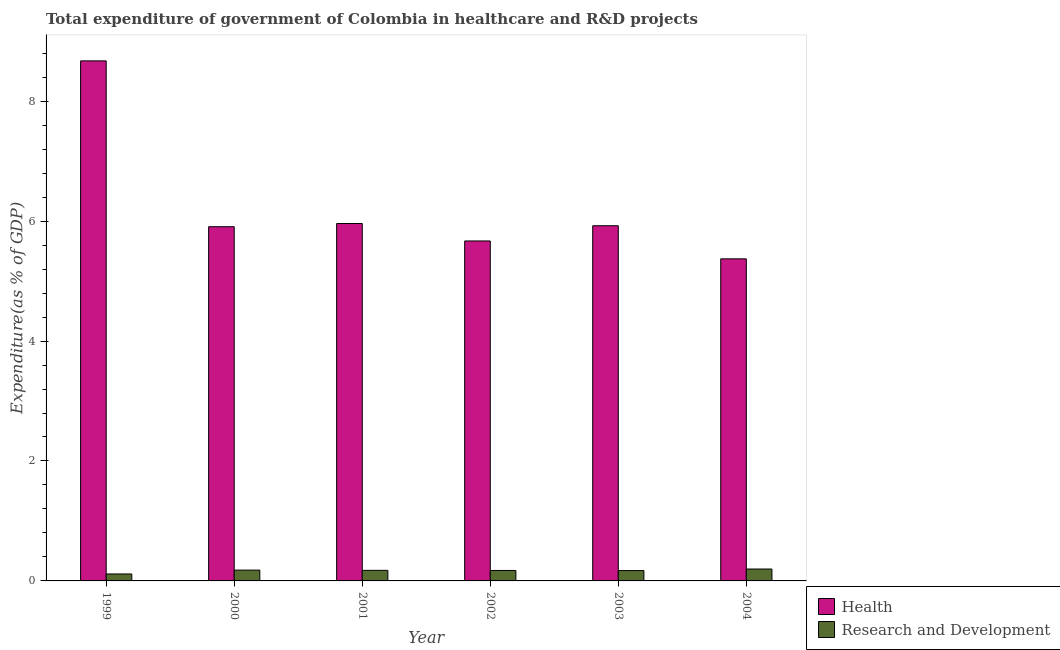How many groups of bars are there?
Provide a short and direct response. 6. How many bars are there on the 4th tick from the left?
Keep it short and to the point. 2. What is the expenditure in healthcare in 2003?
Your response must be concise. 5.92. Across all years, what is the maximum expenditure in healthcare?
Your response must be concise. 8.67. Across all years, what is the minimum expenditure in r&d?
Your answer should be very brief. 0.12. In which year was the expenditure in r&d maximum?
Your answer should be very brief. 2004. In which year was the expenditure in r&d minimum?
Your answer should be very brief. 1999. What is the total expenditure in r&d in the graph?
Provide a succinct answer. 1.02. What is the difference between the expenditure in r&d in 2000 and that in 2001?
Offer a very short reply. 0. What is the difference between the expenditure in r&d in 1999 and the expenditure in healthcare in 2000?
Give a very brief answer. -0.06. What is the average expenditure in r&d per year?
Ensure brevity in your answer.  0.17. In how many years, is the expenditure in healthcare greater than 8.4 %?
Keep it short and to the point. 1. What is the ratio of the expenditure in healthcare in 2001 to that in 2004?
Your answer should be compact. 1.11. Is the expenditure in healthcare in 2000 less than that in 2001?
Your response must be concise. Yes. What is the difference between the highest and the second highest expenditure in healthcare?
Offer a terse response. 2.71. What is the difference between the highest and the lowest expenditure in healthcare?
Your answer should be very brief. 3.3. What does the 2nd bar from the left in 2003 represents?
Ensure brevity in your answer.  Research and Development. What does the 2nd bar from the right in 2003 represents?
Provide a short and direct response. Health. Are all the bars in the graph horizontal?
Give a very brief answer. No. What is the difference between two consecutive major ticks on the Y-axis?
Keep it short and to the point. 2. What is the title of the graph?
Your answer should be compact. Total expenditure of government of Colombia in healthcare and R&D projects. Does "Commercial bank branches" appear as one of the legend labels in the graph?
Your answer should be very brief. No. What is the label or title of the Y-axis?
Offer a terse response. Expenditure(as % of GDP). What is the Expenditure(as % of GDP) in Health in 1999?
Offer a very short reply. 8.67. What is the Expenditure(as % of GDP) of Research and Development in 1999?
Keep it short and to the point. 0.12. What is the Expenditure(as % of GDP) of Health in 2000?
Offer a terse response. 5.91. What is the Expenditure(as % of GDP) in Research and Development in 2000?
Your answer should be very brief. 0.18. What is the Expenditure(as % of GDP) in Health in 2001?
Provide a short and direct response. 5.96. What is the Expenditure(as % of GDP) in Research and Development in 2001?
Ensure brevity in your answer.  0.18. What is the Expenditure(as % of GDP) in Health in 2002?
Give a very brief answer. 5.67. What is the Expenditure(as % of GDP) in Research and Development in 2002?
Your response must be concise. 0.17. What is the Expenditure(as % of GDP) of Health in 2003?
Offer a very short reply. 5.92. What is the Expenditure(as % of GDP) of Research and Development in 2003?
Your answer should be compact. 0.17. What is the Expenditure(as % of GDP) in Health in 2004?
Offer a terse response. 5.37. What is the Expenditure(as % of GDP) of Research and Development in 2004?
Your response must be concise. 0.2. Across all years, what is the maximum Expenditure(as % of GDP) of Health?
Ensure brevity in your answer.  8.67. Across all years, what is the maximum Expenditure(as % of GDP) of Research and Development?
Ensure brevity in your answer.  0.2. Across all years, what is the minimum Expenditure(as % of GDP) of Health?
Your answer should be very brief. 5.37. Across all years, what is the minimum Expenditure(as % of GDP) of Research and Development?
Make the answer very short. 0.12. What is the total Expenditure(as % of GDP) of Health in the graph?
Give a very brief answer. 37.5. What is the total Expenditure(as % of GDP) of Research and Development in the graph?
Keep it short and to the point. 1.02. What is the difference between the Expenditure(as % of GDP) in Health in 1999 and that in 2000?
Your response must be concise. 2.77. What is the difference between the Expenditure(as % of GDP) of Research and Development in 1999 and that in 2000?
Offer a very short reply. -0.06. What is the difference between the Expenditure(as % of GDP) of Health in 1999 and that in 2001?
Your response must be concise. 2.71. What is the difference between the Expenditure(as % of GDP) of Research and Development in 1999 and that in 2001?
Offer a terse response. -0.06. What is the difference between the Expenditure(as % of GDP) of Health in 1999 and that in 2002?
Your answer should be very brief. 3. What is the difference between the Expenditure(as % of GDP) of Research and Development in 1999 and that in 2002?
Your answer should be compact. -0.06. What is the difference between the Expenditure(as % of GDP) of Health in 1999 and that in 2003?
Ensure brevity in your answer.  2.75. What is the difference between the Expenditure(as % of GDP) in Research and Development in 1999 and that in 2003?
Ensure brevity in your answer.  -0.06. What is the difference between the Expenditure(as % of GDP) of Health in 1999 and that in 2004?
Ensure brevity in your answer.  3.3. What is the difference between the Expenditure(as % of GDP) in Research and Development in 1999 and that in 2004?
Ensure brevity in your answer.  -0.08. What is the difference between the Expenditure(as % of GDP) of Health in 2000 and that in 2001?
Your answer should be very brief. -0.05. What is the difference between the Expenditure(as % of GDP) of Research and Development in 2000 and that in 2001?
Make the answer very short. 0. What is the difference between the Expenditure(as % of GDP) of Health in 2000 and that in 2002?
Your response must be concise. 0.24. What is the difference between the Expenditure(as % of GDP) in Research and Development in 2000 and that in 2002?
Your response must be concise. 0.01. What is the difference between the Expenditure(as % of GDP) in Health in 2000 and that in 2003?
Your response must be concise. -0.02. What is the difference between the Expenditure(as % of GDP) in Research and Development in 2000 and that in 2003?
Offer a terse response. 0.01. What is the difference between the Expenditure(as % of GDP) of Health in 2000 and that in 2004?
Give a very brief answer. 0.54. What is the difference between the Expenditure(as % of GDP) of Research and Development in 2000 and that in 2004?
Ensure brevity in your answer.  -0.02. What is the difference between the Expenditure(as % of GDP) of Health in 2001 and that in 2002?
Provide a succinct answer. 0.29. What is the difference between the Expenditure(as % of GDP) of Research and Development in 2001 and that in 2002?
Offer a very short reply. 0. What is the difference between the Expenditure(as % of GDP) in Health in 2001 and that in 2003?
Provide a succinct answer. 0.04. What is the difference between the Expenditure(as % of GDP) in Research and Development in 2001 and that in 2003?
Your answer should be compact. 0. What is the difference between the Expenditure(as % of GDP) in Health in 2001 and that in 2004?
Keep it short and to the point. 0.59. What is the difference between the Expenditure(as % of GDP) of Research and Development in 2001 and that in 2004?
Your answer should be compact. -0.02. What is the difference between the Expenditure(as % of GDP) of Health in 2002 and that in 2003?
Make the answer very short. -0.25. What is the difference between the Expenditure(as % of GDP) in Research and Development in 2002 and that in 2003?
Provide a succinct answer. 0. What is the difference between the Expenditure(as % of GDP) in Health in 2002 and that in 2004?
Ensure brevity in your answer.  0.3. What is the difference between the Expenditure(as % of GDP) of Research and Development in 2002 and that in 2004?
Provide a succinct answer. -0.02. What is the difference between the Expenditure(as % of GDP) in Health in 2003 and that in 2004?
Your response must be concise. 0.55. What is the difference between the Expenditure(as % of GDP) in Research and Development in 2003 and that in 2004?
Offer a terse response. -0.03. What is the difference between the Expenditure(as % of GDP) in Health in 1999 and the Expenditure(as % of GDP) in Research and Development in 2000?
Provide a short and direct response. 8.49. What is the difference between the Expenditure(as % of GDP) in Health in 1999 and the Expenditure(as % of GDP) in Research and Development in 2001?
Provide a succinct answer. 8.5. What is the difference between the Expenditure(as % of GDP) of Health in 1999 and the Expenditure(as % of GDP) of Research and Development in 2002?
Ensure brevity in your answer.  8.5. What is the difference between the Expenditure(as % of GDP) in Health in 1999 and the Expenditure(as % of GDP) in Research and Development in 2003?
Your response must be concise. 8.5. What is the difference between the Expenditure(as % of GDP) in Health in 1999 and the Expenditure(as % of GDP) in Research and Development in 2004?
Give a very brief answer. 8.47. What is the difference between the Expenditure(as % of GDP) of Health in 2000 and the Expenditure(as % of GDP) of Research and Development in 2001?
Ensure brevity in your answer.  5.73. What is the difference between the Expenditure(as % of GDP) of Health in 2000 and the Expenditure(as % of GDP) of Research and Development in 2002?
Your answer should be compact. 5.73. What is the difference between the Expenditure(as % of GDP) of Health in 2000 and the Expenditure(as % of GDP) of Research and Development in 2003?
Offer a terse response. 5.73. What is the difference between the Expenditure(as % of GDP) of Health in 2000 and the Expenditure(as % of GDP) of Research and Development in 2004?
Your response must be concise. 5.71. What is the difference between the Expenditure(as % of GDP) in Health in 2001 and the Expenditure(as % of GDP) in Research and Development in 2002?
Offer a very short reply. 5.79. What is the difference between the Expenditure(as % of GDP) in Health in 2001 and the Expenditure(as % of GDP) in Research and Development in 2003?
Keep it short and to the point. 5.79. What is the difference between the Expenditure(as % of GDP) in Health in 2001 and the Expenditure(as % of GDP) in Research and Development in 2004?
Offer a very short reply. 5.76. What is the difference between the Expenditure(as % of GDP) of Health in 2002 and the Expenditure(as % of GDP) of Research and Development in 2003?
Ensure brevity in your answer.  5.5. What is the difference between the Expenditure(as % of GDP) in Health in 2002 and the Expenditure(as % of GDP) in Research and Development in 2004?
Make the answer very short. 5.47. What is the difference between the Expenditure(as % of GDP) of Health in 2003 and the Expenditure(as % of GDP) of Research and Development in 2004?
Your answer should be very brief. 5.72. What is the average Expenditure(as % of GDP) of Health per year?
Offer a terse response. 6.25. What is the average Expenditure(as % of GDP) of Research and Development per year?
Give a very brief answer. 0.17. In the year 1999, what is the difference between the Expenditure(as % of GDP) of Health and Expenditure(as % of GDP) of Research and Development?
Keep it short and to the point. 8.56. In the year 2000, what is the difference between the Expenditure(as % of GDP) of Health and Expenditure(as % of GDP) of Research and Development?
Your answer should be very brief. 5.73. In the year 2001, what is the difference between the Expenditure(as % of GDP) in Health and Expenditure(as % of GDP) in Research and Development?
Provide a short and direct response. 5.78. In the year 2002, what is the difference between the Expenditure(as % of GDP) of Health and Expenditure(as % of GDP) of Research and Development?
Give a very brief answer. 5.49. In the year 2003, what is the difference between the Expenditure(as % of GDP) of Health and Expenditure(as % of GDP) of Research and Development?
Make the answer very short. 5.75. In the year 2004, what is the difference between the Expenditure(as % of GDP) of Health and Expenditure(as % of GDP) of Research and Development?
Your response must be concise. 5.17. What is the ratio of the Expenditure(as % of GDP) in Health in 1999 to that in 2000?
Your response must be concise. 1.47. What is the ratio of the Expenditure(as % of GDP) of Research and Development in 1999 to that in 2000?
Make the answer very short. 0.64. What is the ratio of the Expenditure(as % of GDP) of Health in 1999 to that in 2001?
Keep it short and to the point. 1.46. What is the ratio of the Expenditure(as % of GDP) of Research and Development in 1999 to that in 2001?
Your answer should be compact. 0.66. What is the ratio of the Expenditure(as % of GDP) in Health in 1999 to that in 2002?
Give a very brief answer. 1.53. What is the ratio of the Expenditure(as % of GDP) of Research and Development in 1999 to that in 2002?
Your answer should be very brief. 0.66. What is the ratio of the Expenditure(as % of GDP) in Health in 1999 to that in 2003?
Offer a very short reply. 1.46. What is the ratio of the Expenditure(as % of GDP) in Research and Development in 1999 to that in 2003?
Offer a terse response. 0.67. What is the ratio of the Expenditure(as % of GDP) in Health in 1999 to that in 2004?
Keep it short and to the point. 1.61. What is the ratio of the Expenditure(as % of GDP) in Research and Development in 1999 to that in 2004?
Ensure brevity in your answer.  0.58. What is the ratio of the Expenditure(as % of GDP) in Research and Development in 2000 to that in 2001?
Make the answer very short. 1.02. What is the ratio of the Expenditure(as % of GDP) in Health in 2000 to that in 2002?
Your answer should be compact. 1.04. What is the ratio of the Expenditure(as % of GDP) of Research and Development in 2000 to that in 2002?
Keep it short and to the point. 1.03. What is the ratio of the Expenditure(as % of GDP) in Research and Development in 2000 to that in 2003?
Your response must be concise. 1.04. What is the ratio of the Expenditure(as % of GDP) of Health in 2000 to that in 2004?
Make the answer very short. 1.1. What is the ratio of the Expenditure(as % of GDP) of Research and Development in 2000 to that in 2004?
Provide a succinct answer. 0.91. What is the ratio of the Expenditure(as % of GDP) of Health in 2001 to that in 2002?
Ensure brevity in your answer.  1.05. What is the ratio of the Expenditure(as % of GDP) of Research and Development in 2001 to that in 2002?
Offer a very short reply. 1.01. What is the ratio of the Expenditure(as % of GDP) in Research and Development in 2001 to that in 2003?
Your answer should be compact. 1.02. What is the ratio of the Expenditure(as % of GDP) in Health in 2001 to that in 2004?
Give a very brief answer. 1.11. What is the ratio of the Expenditure(as % of GDP) in Research and Development in 2001 to that in 2004?
Ensure brevity in your answer.  0.89. What is the ratio of the Expenditure(as % of GDP) in Health in 2002 to that in 2003?
Offer a terse response. 0.96. What is the ratio of the Expenditure(as % of GDP) of Research and Development in 2002 to that in 2003?
Your response must be concise. 1.01. What is the ratio of the Expenditure(as % of GDP) of Health in 2002 to that in 2004?
Your response must be concise. 1.06. What is the ratio of the Expenditure(as % of GDP) in Research and Development in 2002 to that in 2004?
Offer a terse response. 0.88. What is the ratio of the Expenditure(as % of GDP) in Health in 2003 to that in 2004?
Your response must be concise. 1.1. What is the ratio of the Expenditure(as % of GDP) in Research and Development in 2003 to that in 2004?
Give a very brief answer. 0.87. What is the difference between the highest and the second highest Expenditure(as % of GDP) of Health?
Offer a terse response. 2.71. What is the difference between the highest and the second highest Expenditure(as % of GDP) of Research and Development?
Provide a succinct answer. 0.02. What is the difference between the highest and the lowest Expenditure(as % of GDP) in Health?
Provide a short and direct response. 3.3. What is the difference between the highest and the lowest Expenditure(as % of GDP) of Research and Development?
Your response must be concise. 0.08. 